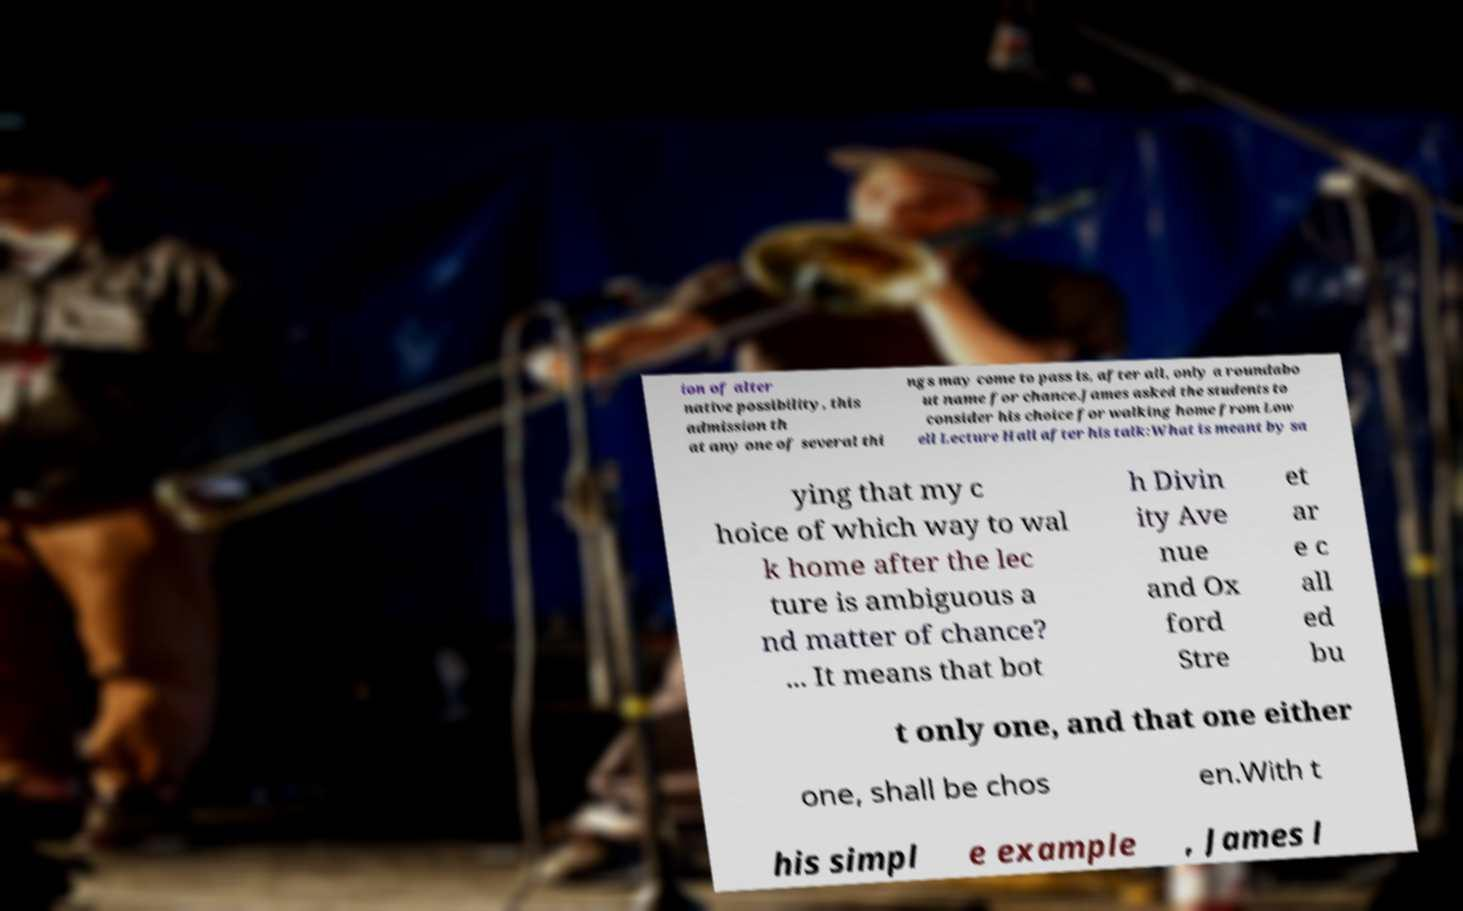Please read and relay the text visible in this image. What does it say? ion of alter native possibility, this admission th at any one of several thi ngs may come to pass is, after all, only a roundabo ut name for chance.James asked the students to consider his choice for walking home from Low ell Lecture Hall after his talk:What is meant by sa ying that my c hoice of which way to wal k home after the lec ture is ambiguous a nd matter of chance? ... It means that bot h Divin ity Ave nue and Ox ford Stre et ar e c all ed bu t only one, and that one either one, shall be chos en.With t his simpl e example , James l 